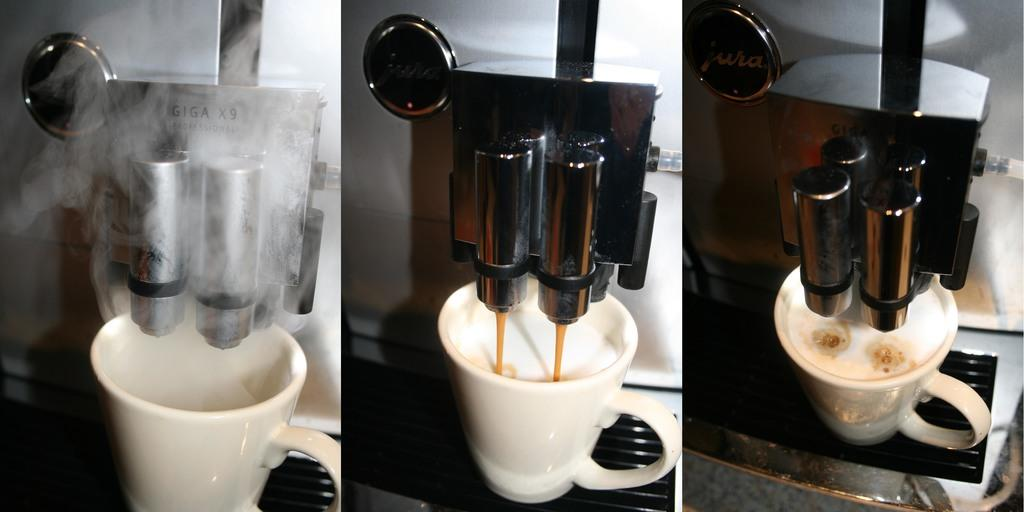How many images are combined to create the collage in the image? The image is a collage of three images. What can be seen in one of the images? There is a coffee making machine in one of the images. What is present in another image within the collage? There is a cup in one of the images. What type of spoon is being used to stir the feast in the image? There is no feast or spoon present in the image. Can you describe the stream that runs through the image? There is no stream present in the image; it is a collage of three images, one of which features a coffee making machine and another with a cup. 